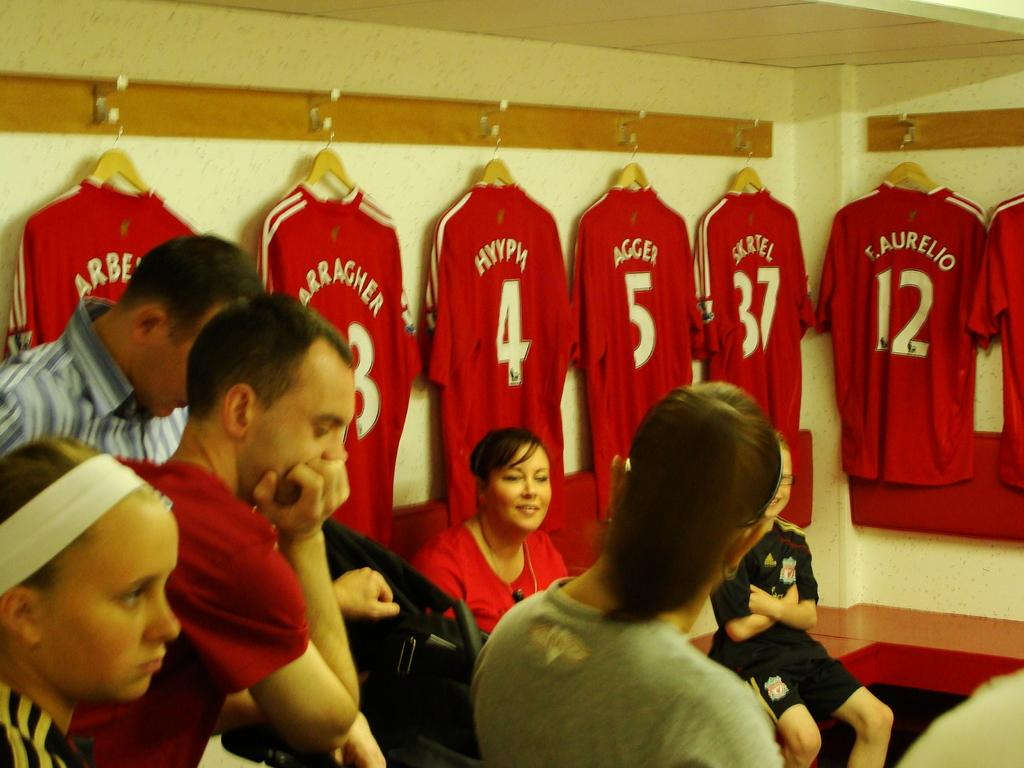<image>
Write a terse but informative summary of the picture. F. Aurelio is player #12 on the team. 